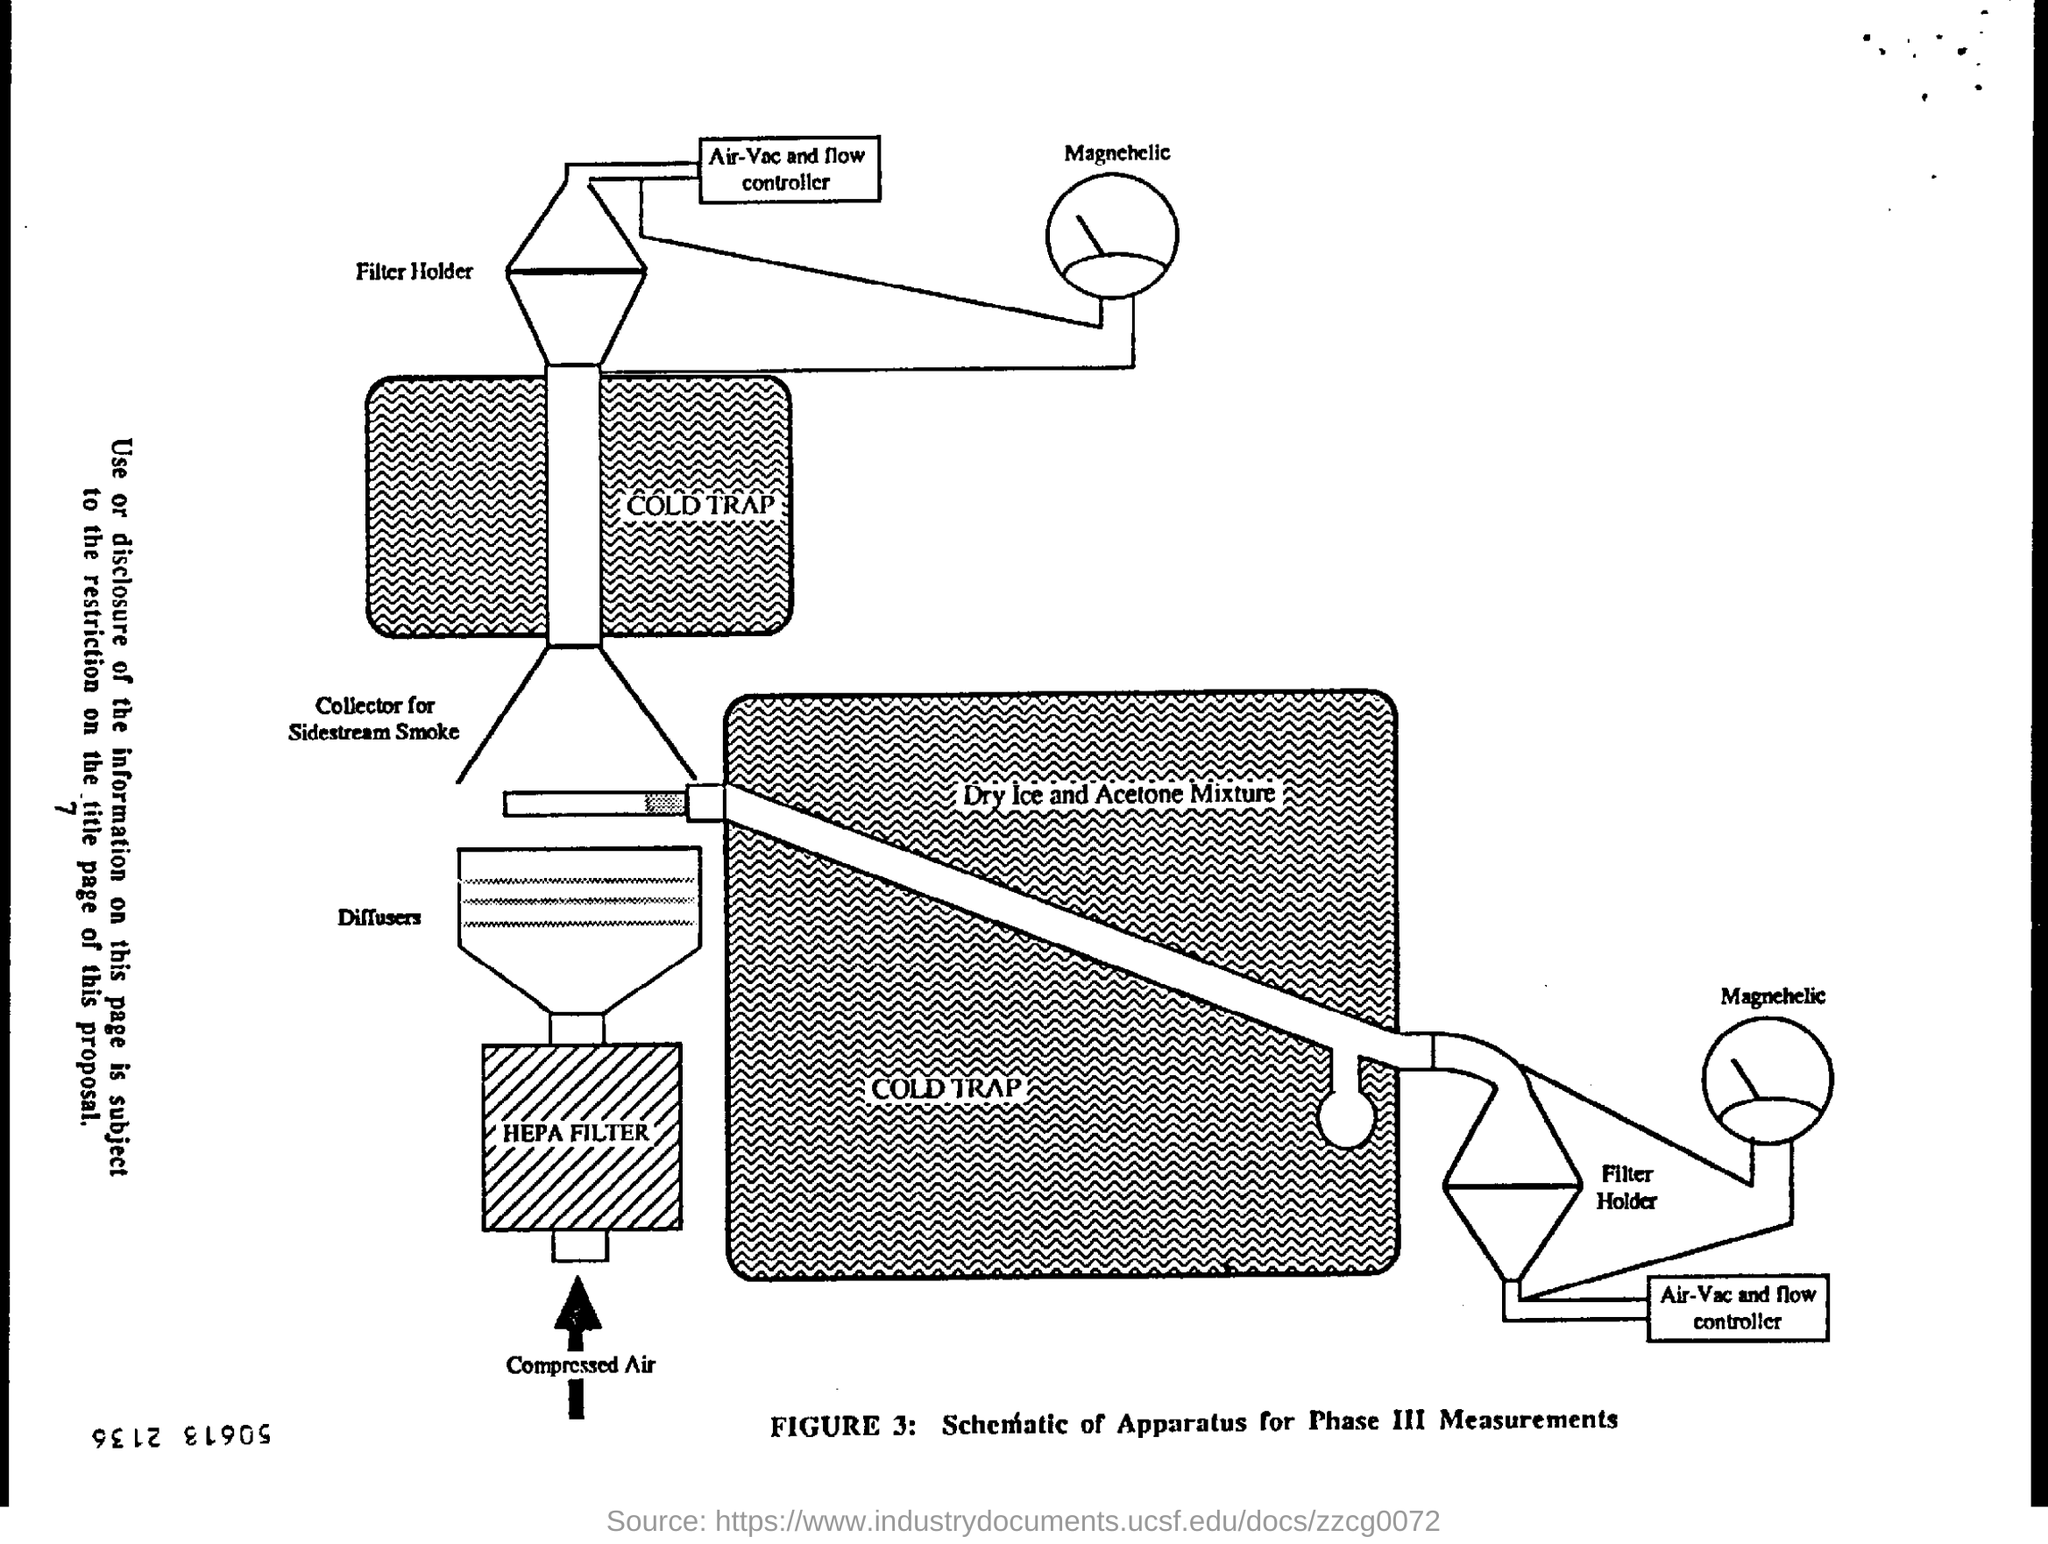Identify some key points in this picture. Figure 3 presents a schematic of the apparatus used for phase III measurements, which is titled... The cold trap contains a mixture of dry ice and acetone. 